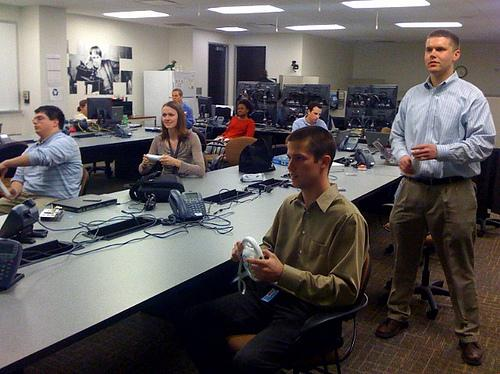What is the man in the brown shirt emulating with the white controller? driving 